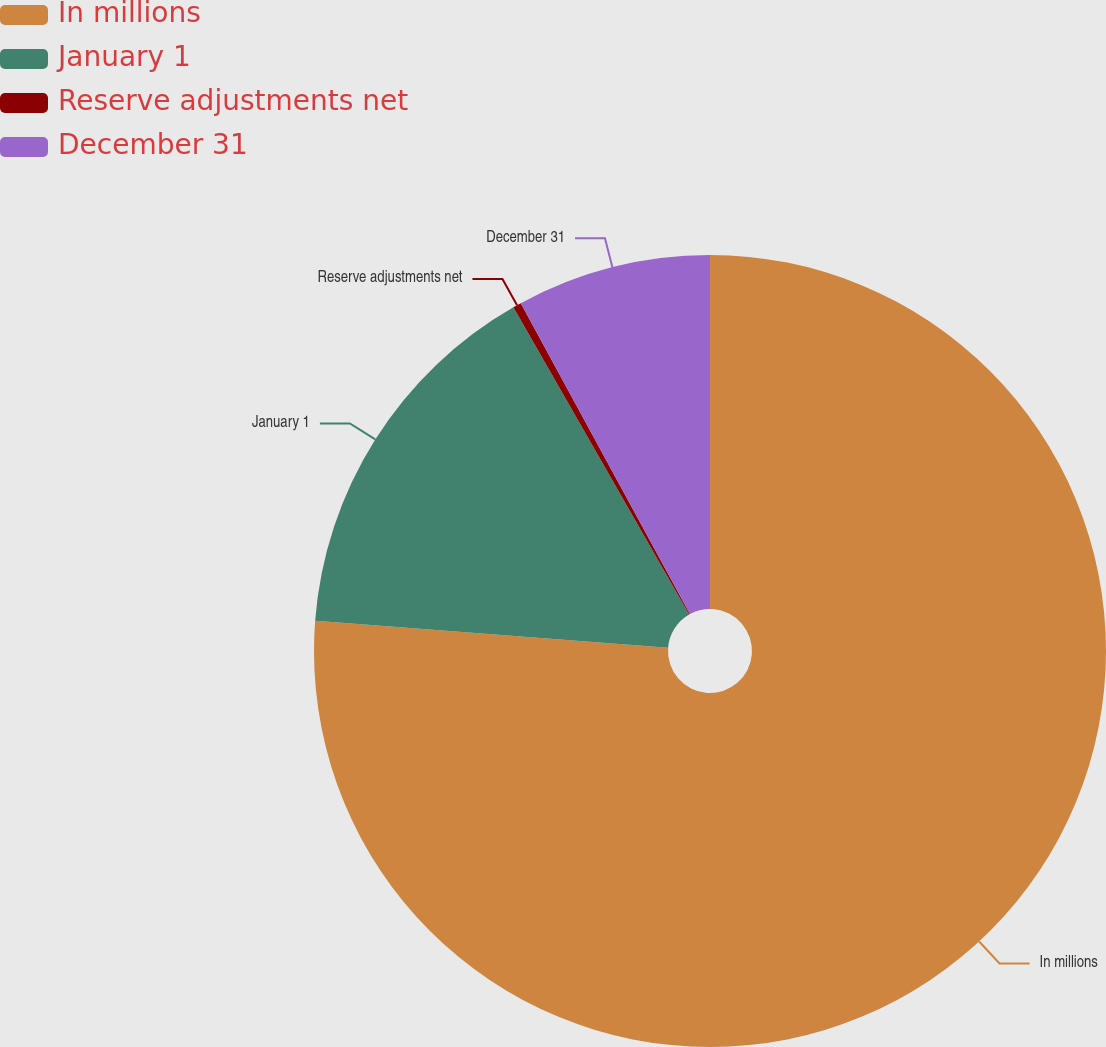Convert chart. <chart><loc_0><loc_0><loc_500><loc_500><pie_chart><fcel>In millions<fcel>January 1<fcel>Reserve adjustments net<fcel>December 31<nl><fcel>76.22%<fcel>15.52%<fcel>0.34%<fcel>7.93%<nl></chart> 